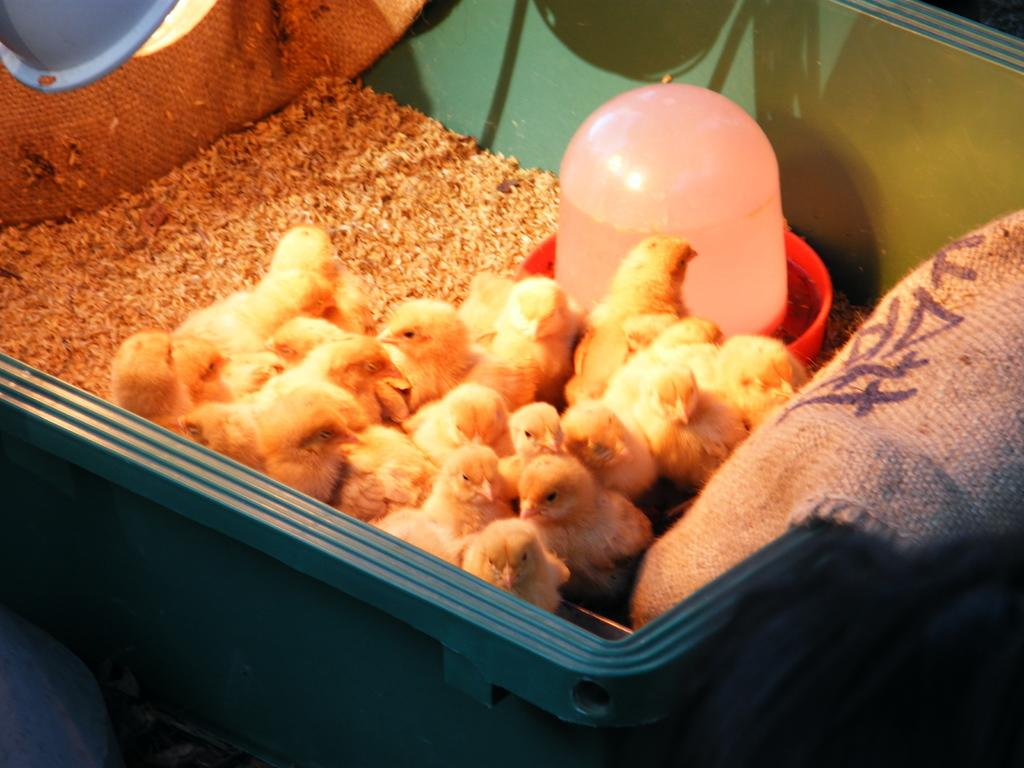What type of animals are in the box in the image? There are chicks in the box in the image. What is the purpose of the bowl in the image? There is a bowl of water in the image, which might be for the chicks to drink or bathe. What is placed on the left side of the image? There is food placed on the left side of the image. What color is the box containing the chicks? The box is blue in color. How many shelves are visible in the image? There are no shelves visible in the image. What unit of measurement is used to determine the size of the chicks? The size of the chicks cannot be determined from the image alone, and there is no mention of a specific unit of measurement. 